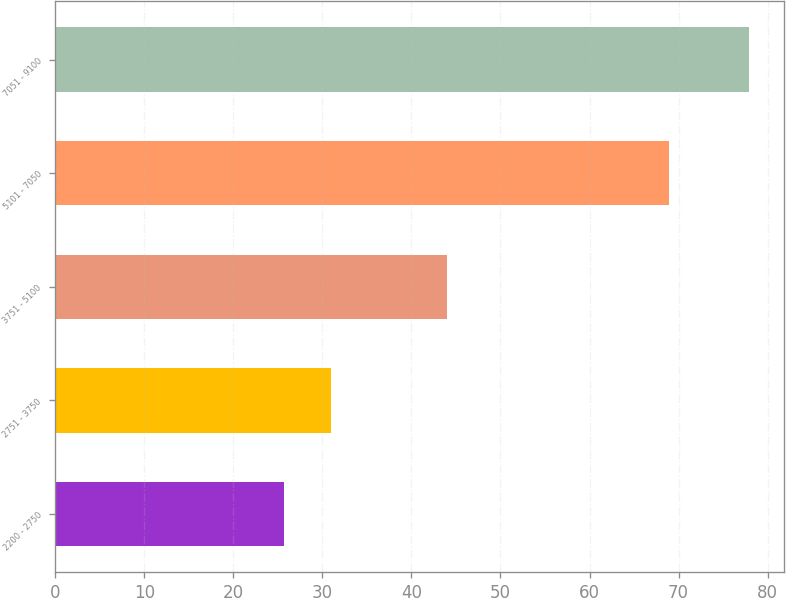<chart> <loc_0><loc_0><loc_500><loc_500><bar_chart><fcel>2200 - 2750<fcel>2751 - 3750<fcel>3751 - 5100<fcel>5101 - 7050<fcel>7051 - 9100<nl><fcel>25.73<fcel>30.95<fcel>44.01<fcel>68.97<fcel>77.95<nl></chart> 